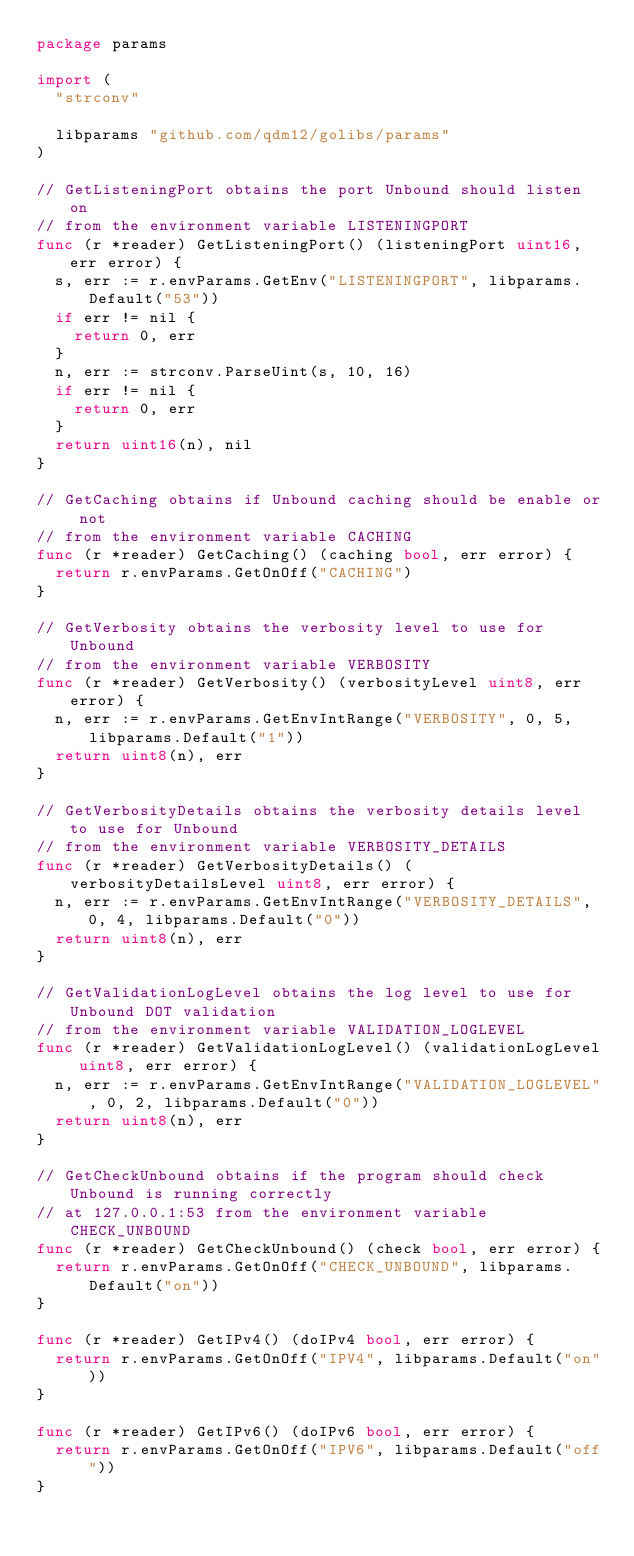Convert code to text. <code><loc_0><loc_0><loc_500><loc_500><_Go_>package params

import (
	"strconv"

	libparams "github.com/qdm12/golibs/params"
)

// GetListeningPort obtains the port Unbound should listen on
// from the environment variable LISTENINGPORT
func (r *reader) GetListeningPort() (listeningPort uint16, err error) {
	s, err := r.envParams.GetEnv("LISTENINGPORT", libparams.Default("53"))
	if err != nil {
		return 0, err
	}
	n, err := strconv.ParseUint(s, 10, 16)
	if err != nil {
		return 0, err
	}
	return uint16(n), nil
}

// GetCaching obtains if Unbound caching should be enable or not
// from the environment variable CACHING
func (r *reader) GetCaching() (caching bool, err error) {
	return r.envParams.GetOnOff("CACHING")
}

// GetVerbosity obtains the verbosity level to use for Unbound
// from the environment variable VERBOSITY
func (r *reader) GetVerbosity() (verbosityLevel uint8, err error) {
	n, err := r.envParams.GetEnvIntRange("VERBOSITY", 0, 5, libparams.Default("1"))
	return uint8(n), err
}

// GetVerbosityDetails obtains the verbosity details level to use for Unbound
// from the environment variable VERBOSITY_DETAILS
func (r *reader) GetVerbosityDetails() (verbosityDetailsLevel uint8, err error) {
	n, err := r.envParams.GetEnvIntRange("VERBOSITY_DETAILS", 0, 4, libparams.Default("0"))
	return uint8(n), err
}

// GetValidationLogLevel obtains the log level to use for Unbound DOT validation
// from the environment variable VALIDATION_LOGLEVEL
func (r *reader) GetValidationLogLevel() (validationLogLevel uint8, err error) {
	n, err := r.envParams.GetEnvIntRange("VALIDATION_LOGLEVEL", 0, 2, libparams.Default("0"))
	return uint8(n), err
}

// GetCheckUnbound obtains if the program should check Unbound is running correctly
// at 127.0.0.1:53 from the environment variable CHECK_UNBOUND
func (r *reader) GetCheckUnbound() (check bool, err error) {
	return r.envParams.GetOnOff("CHECK_UNBOUND", libparams.Default("on"))
}

func (r *reader) GetIPv4() (doIPv4 bool, err error) {
	return r.envParams.GetOnOff("IPV4", libparams.Default("on"))
}

func (r *reader) GetIPv6() (doIPv6 bool, err error) {
	return r.envParams.GetOnOff("IPV6", libparams.Default("off"))
}
</code> 